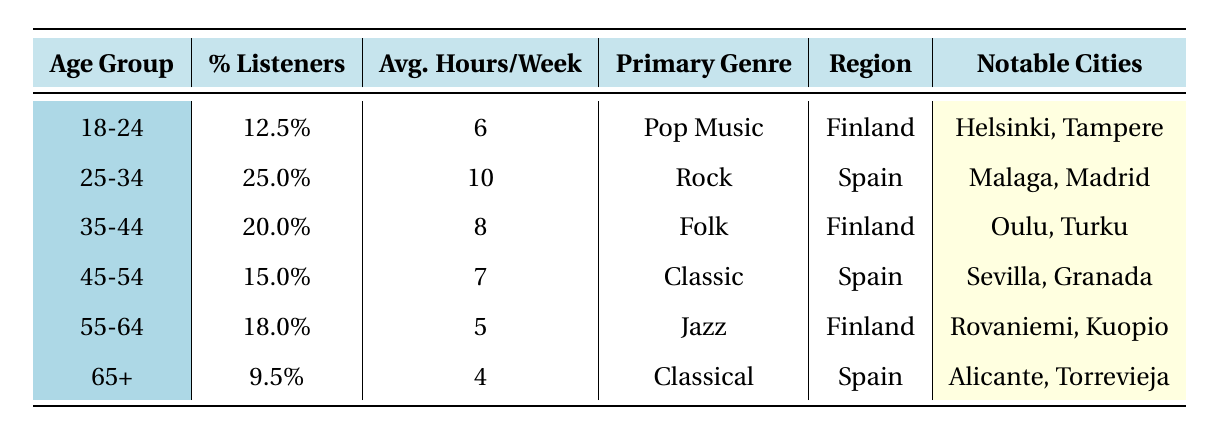What percentage of listeners are aged 25-34? From the table, the age group of 25-34 has a percent listeners value of 25.0%.
Answer: 25.0% What is the primary genre for listeners aged 55-64? According to the table, the primary genre for the age group 55-64 is Jazz.
Answer: Jazz Which age group spends the most hours listening per week? The age group 25-34 spends the most hours listening per week, with an average of 10 hours.
Answer: 25-34 How many percent of listeners are in the age group 65+? The table indicates that the age group 65+ makes up 9.5% of the listeners.
Answer: 9.5% What genre is primarily listened to by the 45-54 age group? The primary genre for the age group 45-54 is Classic.
Answer: Classic If a listener in the 18-24 age group listens for an average of 6 hours, how much more do listeners in the 25-34 age group listen on average? The average hours per week for the 25-34 age group is 10 hours, while the 18-24 age group listens for 6 hours. The difference is 10 - 6 = 4 hours.
Answer: 4 hours Is the average listening time for the 55-64 age group higher than that for the 65+ age group? The 55-64 age group has an average of 5 hours per week while the 65+ age group has 4 hours. Since 5 is greater than 4, the statement is true.
Answer: Yes What is the average percent of listeners across all age groups? To find the average, add all the percent listeners: 12.5 + 25.0 + 20.0 + 15.0 + 18.0 + 9.5 = 100.0, then divide by the number of age groups (6). So 100.0 / 6 ≈ 16.67%.
Answer: 16.67% Which region has the highest percent of listeners in the age group 35-44? The table shows that the 35-44 age group is primarily from Finland, which does not have competing values; thus, Finland is confirmed to be the region with the highest percent of listeners for this age group.
Answer: Finland How many notable cities are listed for listeners aged 45-54? The table states there are two notable cities listed for the age group 45-54: Sevilla and Granada.
Answer: 2 cities Which age group listens the least on average per week? The age group 65+ has the lowest average listening hours at 4 hours per week, compared to all other age groups.
Answer: 65+ 